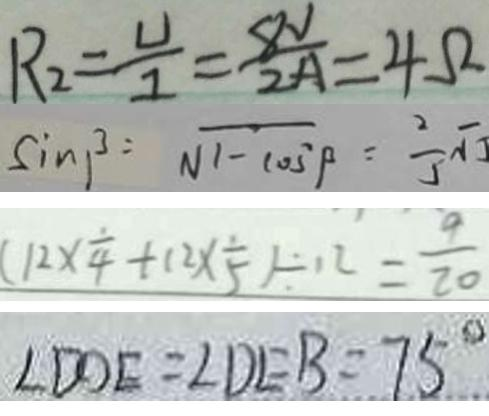Convert formula to latex. <formula><loc_0><loc_0><loc_500><loc_500>R _ { 2 } = \frac { U } { I } = \frac { 8 V } { 2 A } = 4 \Omega 
 \sin \beta = \sqrt { 1 - \cos ^ { 2 } \beta } = \frac { 2 } { 5 } \sqrt { 5 } 
 ( 1 2 \times \frac { 1 } { 4 } + 1 2 \times \frac { 1 } { 5 } ) \div 1 2 = \frac { 9 } { 2 0 } 
 \angle D D E = \angle D E B = 7 5 ^ { \circ }</formula> 